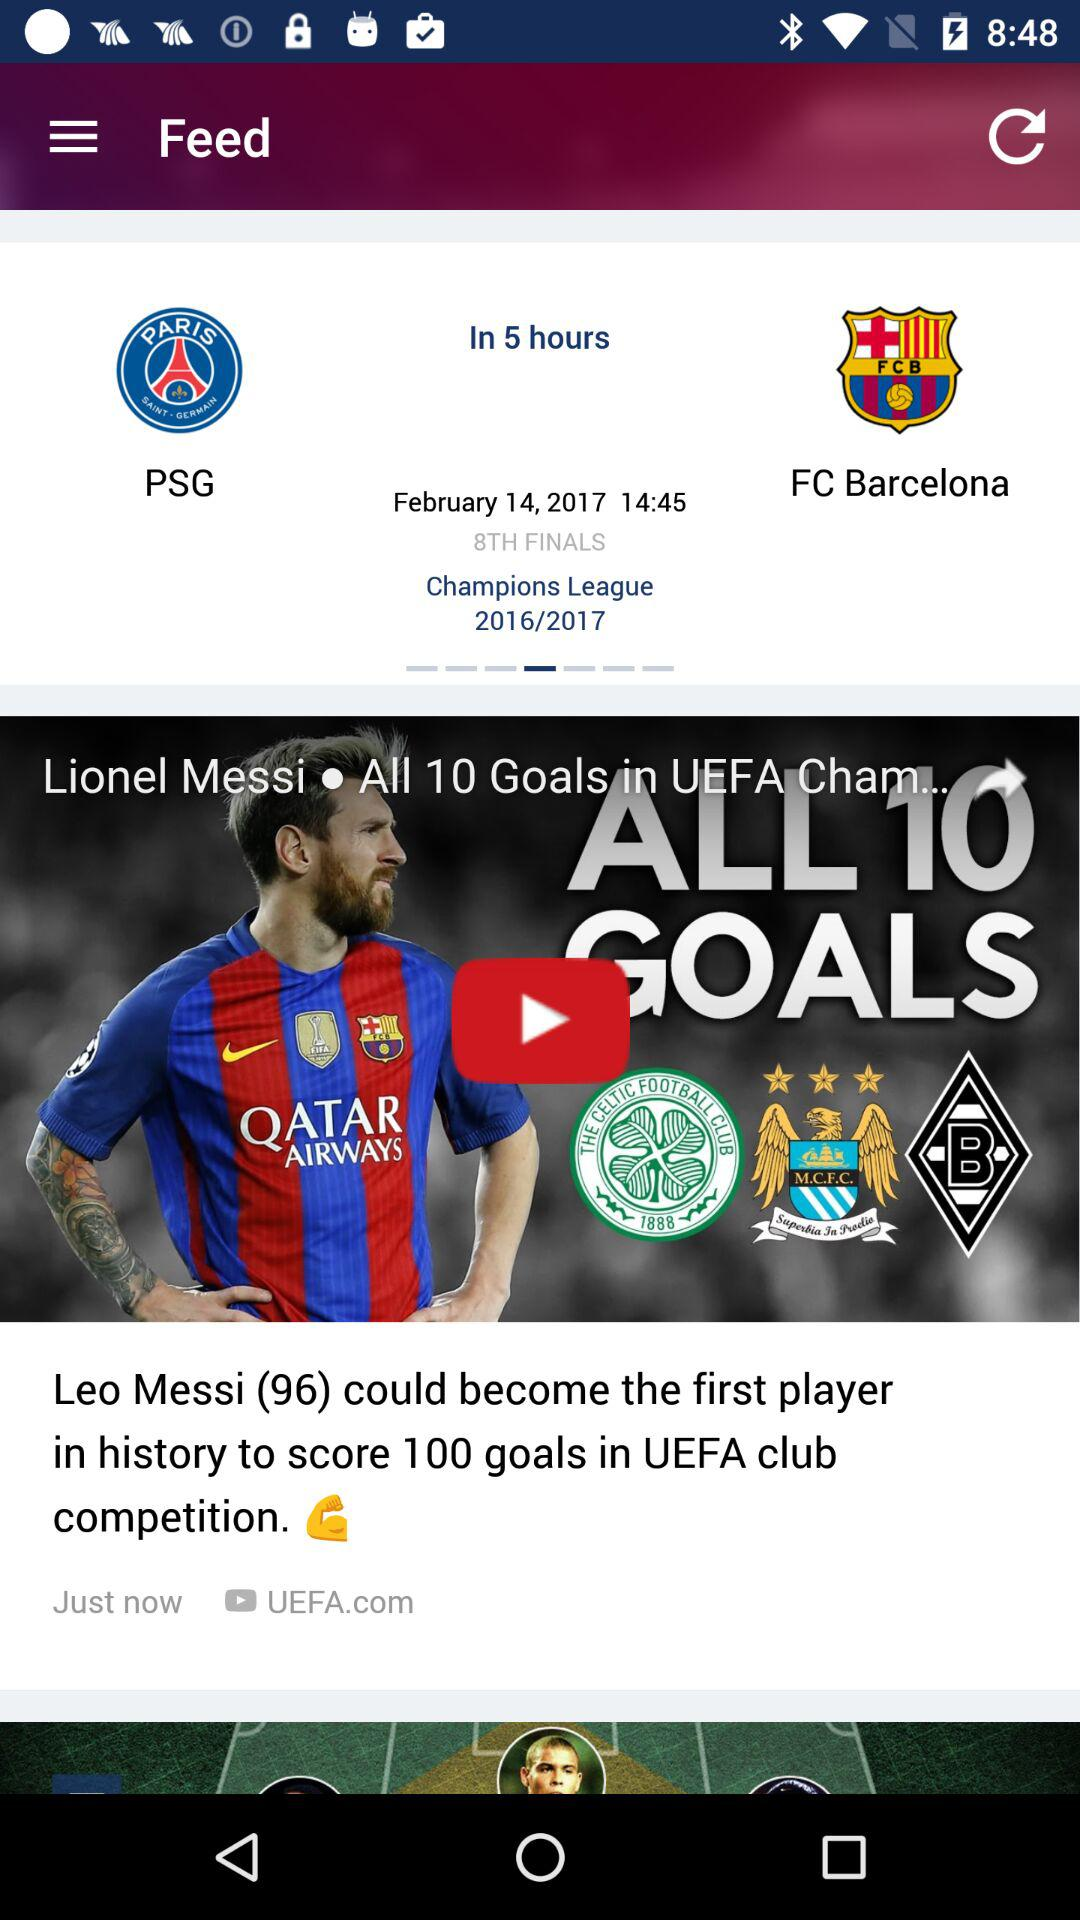How many goals has Leo Messi scored in UEFA club competition?
Answer the question using a single word or phrase. 96 